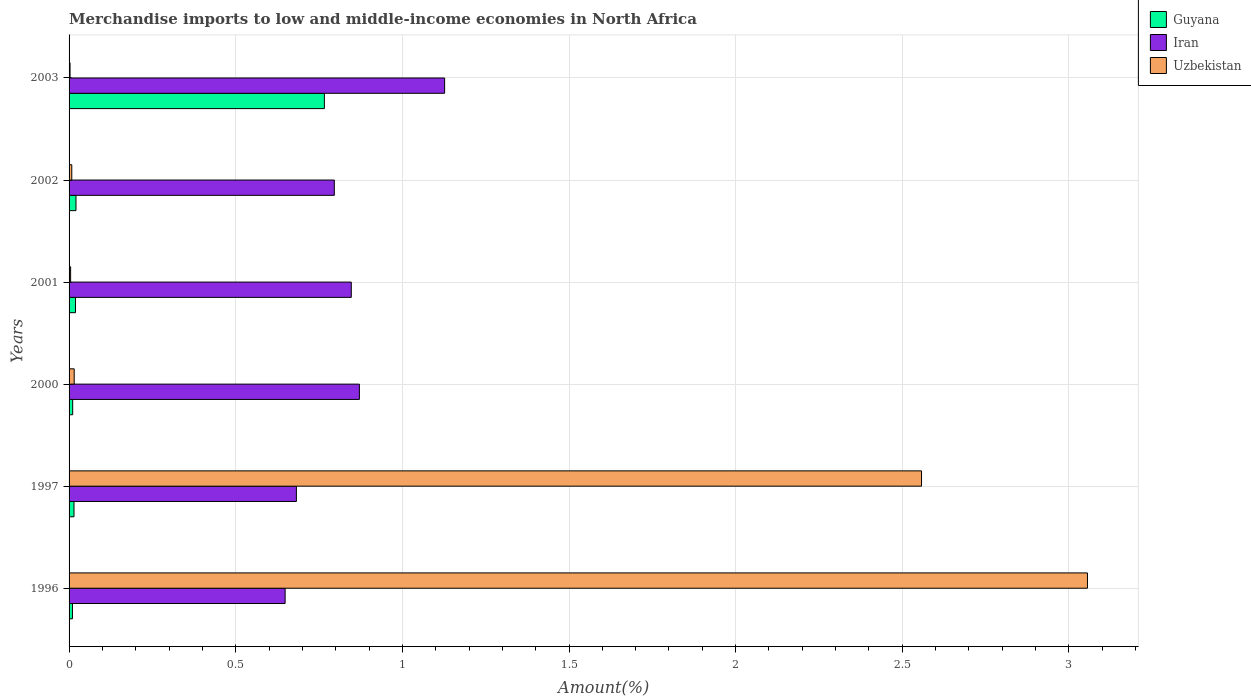How many different coloured bars are there?
Offer a very short reply. 3. How many groups of bars are there?
Give a very brief answer. 6. Are the number of bars per tick equal to the number of legend labels?
Your answer should be very brief. Yes. How many bars are there on the 3rd tick from the top?
Provide a succinct answer. 3. In how many cases, is the number of bars for a given year not equal to the number of legend labels?
Give a very brief answer. 0. What is the percentage of amount earned from merchandise imports in Guyana in 2002?
Ensure brevity in your answer.  0.02. Across all years, what is the maximum percentage of amount earned from merchandise imports in Iran?
Provide a succinct answer. 1.13. Across all years, what is the minimum percentage of amount earned from merchandise imports in Uzbekistan?
Provide a short and direct response. 0. In which year was the percentage of amount earned from merchandise imports in Uzbekistan minimum?
Provide a short and direct response. 2003. What is the total percentage of amount earned from merchandise imports in Guyana in the graph?
Your answer should be compact. 0.84. What is the difference between the percentage of amount earned from merchandise imports in Guyana in 1996 and that in 2002?
Keep it short and to the point. -0.01. What is the difference between the percentage of amount earned from merchandise imports in Uzbekistan in 1997 and the percentage of amount earned from merchandise imports in Iran in 2003?
Your answer should be very brief. 1.43. What is the average percentage of amount earned from merchandise imports in Guyana per year?
Provide a succinct answer. 0.14. In the year 2002, what is the difference between the percentage of amount earned from merchandise imports in Guyana and percentage of amount earned from merchandise imports in Iran?
Keep it short and to the point. -0.78. What is the ratio of the percentage of amount earned from merchandise imports in Iran in 1997 to that in 2002?
Provide a short and direct response. 0.86. What is the difference between the highest and the second highest percentage of amount earned from merchandise imports in Uzbekistan?
Your response must be concise. 0.5. What is the difference between the highest and the lowest percentage of amount earned from merchandise imports in Uzbekistan?
Provide a short and direct response. 3.05. In how many years, is the percentage of amount earned from merchandise imports in Uzbekistan greater than the average percentage of amount earned from merchandise imports in Uzbekistan taken over all years?
Keep it short and to the point. 2. Is the sum of the percentage of amount earned from merchandise imports in Iran in 2002 and 2003 greater than the maximum percentage of amount earned from merchandise imports in Guyana across all years?
Your response must be concise. Yes. What does the 3rd bar from the top in 2001 represents?
Your response must be concise. Guyana. What does the 3rd bar from the bottom in 1997 represents?
Keep it short and to the point. Uzbekistan. Are all the bars in the graph horizontal?
Make the answer very short. Yes. How many years are there in the graph?
Make the answer very short. 6. Are the values on the major ticks of X-axis written in scientific E-notation?
Your response must be concise. No. Does the graph contain any zero values?
Your answer should be compact. No. Does the graph contain grids?
Provide a succinct answer. Yes. Where does the legend appear in the graph?
Offer a terse response. Top right. What is the title of the graph?
Provide a succinct answer. Merchandise imports to low and middle-income economies in North Africa. Does "St. Lucia" appear as one of the legend labels in the graph?
Your response must be concise. No. What is the label or title of the X-axis?
Your answer should be very brief. Amount(%). What is the Amount(%) in Guyana in 1996?
Give a very brief answer. 0.01. What is the Amount(%) of Iran in 1996?
Make the answer very short. 0.65. What is the Amount(%) in Uzbekistan in 1996?
Make the answer very short. 3.06. What is the Amount(%) in Guyana in 1997?
Provide a short and direct response. 0.01. What is the Amount(%) of Iran in 1997?
Your response must be concise. 0.68. What is the Amount(%) of Uzbekistan in 1997?
Ensure brevity in your answer.  2.56. What is the Amount(%) of Guyana in 2000?
Give a very brief answer. 0.01. What is the Amount(%) in Iran in 2000?
Provide a succinct answer. 0.87. What is the Amount(%) of Uzbekistan in 2000?
Your answer should be very brief. 0.02. What is the Amount(%) of Guyana in 2001?
Keep it short and to the point. 0.02. What is the Amount(%) of Iran in 2001?
Keep it short and to the point. 0.85. What is the Amount(%) in Uzbekistan in 2001?
Your response must be concise. 0. What is the Amount(%) in Guyana in 2002?
Your answer should be very brief. 0.02. What is the Amount(%) of Iran in 2002?
Your answer should be compact. 0.8. What is the Amount(%) in Uzbekistan in 2002?
Offer a terse response. 0.01. What is the Amount(%) in Guyana in 2003?
Your answer should be very brief. 0.77. What is the Amount(%) in Iran in 2003?
Make the answer very short. 1.13. What is the Amount(%) of Uzbekistan in 2003?
Provide a short and direct response. 0. Across all years, what is the maximum Amount(%) in Guyana?
Keep it short and to the point. 0.77. Across all years, what is the maximum Amount(%) in Iran?
Provide a succinct answer. 1.13. Across all years, what is the maximum Amount(%) in Uzbekistan?
Give a very brief answer. 3.06. Across all years, what is the minimum Amount(%) in Guyana?
Your answer should be compact. 0.01. Across all years, what is the minimum Amount(%) of Iran?
Provide a short and direct response. 0.65. Across all years, what is the minimum Amount(%) in Uzbekistan?
Provide a short and direct response. 0. What is the total Amount(%) of Guyana in the graph?
Offer a terse response. 0.84. What is the total Amount(%) in Iran in the graph?
Your answer should be compact. 4.97. What is the total Amount(%) of Uzbekistan in the graph?
Provide a succinct answer. 5.64. What is the difference between the Amount(%) of Guyana in 1996 and that in 1997?
Offer a terse response. -0. What is the difference between the Amount(%) in Iran in 1996 and that in 1997?
Offer a terse response. -0.03. What is the difference between the Amount(%) in Uzbekistan in 1996 and that in 1997?
Provide a short and direct response. 0.5. What is the difference between the Amount(%) in Guyana in 1996 and that in 2000?
Your answer should be very brief. -0. What is the difference between the Amount(%) of Iran in 1996 and that in 2000?
Your response must be concise. -0.22. What is the difference between the Amount(%) of Uzbekistan in 1996 and that in 2000?
Your answer should be very brief. 3.04. What is the difference between the Amount(%) in Guyana in 1996 and that in 2001?
Provide a succinct answer. -0.01. What is the difference between the Amount(%) of Iran in 1996 and that in 2001?
Provide a short and direct response. -0.2. What is the difference between the Amount(%) of Uzbekistan in 1996 and that in 2001?
Your answer should be compact. 3.05. What is the difference between the Amount(%) in Guyana in 1996 and that in 2002?
Your answer should be compact. -0.01. What is the difference between the Amount(%) in Iran in 1996 and that in 2002?
Your answer should be very brief. -0.15. What is the difference between the Amount(%) of Uzbekistan in 1996 and that in 2002?
Make the answer very short. 3.05. What is the difference between the Amount(%) of Guyana in 1996 and that in 2003?
Keep it short and to the point. -0.76. What is the difference between the Amount(%) of Iran in 1996 and that in 2003?
Offer a very short reply. -0.48. What is the difference between the Amount(%) in Uzbekistan in 1996 and that in 2003?
Keep it short and to the point. 3.05. What is the difference between the Amount(%) in Guyana in 1997 and that in 2000?
Your response must be concise. 0. What is the difference between the Amount(%) of Iran in 1997 and that in 2000?
Offer a very short reply. -0.19. What is the difference between the Amount(%) of Uzbekistan in 1997 and that in 2000?
Your answer should be compact. 2.54. What is the difference between the Amount(%) of Guyana in 1997 and that in 2001?
Provide a succinct answer. -0. What is the difference between the Amount(%) in Iran in 1997 and that in 2001?
Your answer should be compact. -0.16. What is the difference between the Amount(%) in Uzbekistan in 1997 and that in 2001?
Ensure brevity in your answer.  2.55. What is the difference between the Amount(%) of Guyana in 1997 and that in 2002?
Keep it short and to the point. -0.01. What is the difference between the Amount(%) in Iran in 1997 and that in 2002?
Ensure brevity in your answer.  -0.11. What is the difference between the Amount(%) in Uzbekistan in 1997 and that in 2002?
Provide a short and direct response. 2.55. What is the difference between the Amount(%) in Guyana in 1997 and that in 2003?
Your response must be concise. -0.75. What is the difference between the Amount(%) of Iran in 1997 and that in 2003?
Provide a succinct answer. -0.44. What is the difference between the Amount(%) of Uzbekistan in 1997 and that in 2003?
Provide a succinct answer. 2.55. What is the difference between the Amount(%) in Guyana in 2000 and that in 2001?
Ensure brevity in your answer.  -0.01. What is the difference between the Amount(%) in Iran in 2000 and that in 2001?
Give a very brief answer. 0.02. What is the difference between the Amount(%) of Uzbekistan in 2000 and that in 2001?
Provide a short and direct response. 0.01. What is the difference between the Amount(%) in Guyana in 2000 and that in 2002?
Make the answer very short. -0.01. What is the difference between the Amount(%) in Iran in 2000 and that in 2002?
Your response must be concise. 0.08. What is the difference between the Amount(%) in Uzbekistan in 2000 and that in 2002?
Your answer should be very brief. 0.01. What is the difference between the Amount(%) in Guyana in 2000 and that in 2003?
Your response must be concise. -0.76. What is the difference between the Amount(%) of Iran in 2000 and that in 2003?
Ensure brevity in your answer.  -0.26. What is the difference between the Amount(%) in Uzbekistan in 2000 and that in 2003?
Your answer should be very brief. 0.01. What is the difference between the Amount(%) of Guyana in 2001 and that in 2002?
Your answer should be very brief. -0. What is the difference between the Amount(%) of Iran in 2001 and that in 2002?
Ensure brevity in your answer.  0.05. What is the difference between the Amount(%) of Uzbekistan in 2001 and that in 2002?
Give a very brief answer. -0. What is the difference between the Amount(%) in Guyana in 2001 and that in 2003?
Provide a succinct answer. -0.75. What is the difference between the Amount(%) in Iran in 2001 and that in 2003?
Keep it short and to the point. -0.28. What is the difference between the Amount(%) of Uzbekistan in 2001 and that in 2003?
Provide a succinct answer. 0. What is the difference between the Amount(%) of Guyana in 2002 and that in 2003?
Your answer should be very brief. -0.75. What is the difference between the Amount(%) of Iran in 2002 and that in 2003?
Provide a succinct answer. -0.33. What is the difference between the Amount(%) in Uzbekistan in 2002 and that in 2003?
Offer a very short reply. 0.01. What is the difference between the Amount(%) of Guyana in 1996 and the Amount(%) of Iran in 1997?
Offer a very short reply. -0.67. What is the difference between the Amount(%) of Guyana in 1996 and the Amount(%) of Uzbekistan in 1997?
Provide a succinct answer. -2.55. What is the difference between the Amount(%) of Iran in 1996 and the Amount(%) of Uzbekistan in 1997?
Ensure brevity in your answer.  -1.91. What is the difference between the Amount(%) of Guyana in 1996 and the Amount(%) of Iran in 2000?
Give a very brief answer. -0.86. What is the difference between the Amount(%) of Guyana in 1996 and the Amount(%) of Uzbekistan in 2000?
Provide a short and direct response. -0.01. What is the difference between the Amount(%) of Iran in 1996 and the Amount(%) of Uzbekistan in 2000?
Keep it short and to the point. 0.63. What is the difference between the Amount(%) of Guyana in 1996 and the Amount(%) of Iran in 2001?
Make the answer very short. -0.84. What is the difference between the Amount(%) in Guyana in 1996 and the Amount(%) in Uzbekistan in 2001?
Your answer should be compact. 0.01. What is the difference between the Amount(%) of Iran in 1996 and the Amount(%) of Uzbekistan in 2001?
Your answer should be very brief. 0.64. What is the difference between the Amount(%) of Guyana in 1996 and the Amount(%) of Iran in 2002?
Keep it short and to the point. -0.79. What is the difference between the Amount(%) of Guyana in 1996 and the Amount(%) of Uzbekistan in 2002?
Provide a succinct answer. 0. What is the difference between the Amount(%) of Iran in 1996 and the Amount(%) of Uzbekistan in 2002?
Keep it short and to the point. 0.64. What is the difference between the Amount(%) in Guyana in 1996 and the Amount(%) in Iran in 2003?
Offer a terse response. -1.12. What is the difference between the Amount(%) of Guyana in 1996 and the Amount(%) of Uzbekistan in 2003?
Give a very brief answer. 0.01. What is the difference between the Amount(%) of Iran in 1996 and the Amount(%) of Uzbekistan in 2003?
Your answer should be very brief. 0.65. What is the difference between the Amount(%) of Guyana in 1997 and the Amount(%) of Iran in 2000?
Make the answer very short. -0.86. What is the difference between the Amount(%) of Guyana in 1997 and the Amount(%) of Uzbekistan in 2000?
Offer a terse response. -0. What is the difference between the Amount(%) of Iran in 1997 and the Amount(%) of Uzbekistan in 2000?
Offer a very short reply. 0.67. What is the difference between the Amount(%) in Guyana in 1997 and the Amount(%) in Iran in 2001?
Offer a terse response. -0.83. What is the difference between the Amount(%) of Guyana in 1997 and the Amount(%) of Uzbekistan in 2001?
Your answer should be very brief. 0.01. What is the difference between the Amount(%) of Iran in 1997 and the Amount(%) of Uzbekistan in 2001?
Keep it short and to the point. 0.68. What is the difference between the Amount(%) of Guyana in 1997 and the Amount(%) of Iran in 2002?
Your response must be concise. -0.78. What is the difference between the Amount(%) in Guyana in 1997 and the Amount(%) in Uzbekistan in 2002?
Your response must be concise. 0.01. What is the difference between the Amount(%) in Iran in 1997 and the Amount(%) in Uzbekistan in 2002?
Provide a succinct answer. 0.67. What is the difference between the Amount(%) of Guyana in 1997 and the Amount(%) of Iran in 2003?
Offer a terse response. -1.11. What is the difference between the Amount(%) of Guyana in 1997 and the Amount(%) of Uzbekistan in 2003?
Your answer should be very brief. 0.01. What is the difference between the Amount(%) in Iran in 1997 and the Amount(%) in Uzbekistan in 2003?
Provide a short and direct response. 0.68. What is the difference between the Amount(%) of Guyana in 2000 and the Amount(%) of Iran in 2001?
Your answer should be compact. -0.84. What is the difference between the Amount(%) in Guyana in 2000 and the Amount(%) in Uzbekistan in 2001?
Provide a short and direct response. 0.01. What is the difference between the Amount(%) of Iran in 2000 and the Amount(%) of Uzbekistan in 2001?
Your response must be concise. 0.87. What is the difference between the Amount(%) in Guyana in 2000 and the Amount(%) in Iran in 2002?
Ensure brevity in your answer.  -0.79. What is the difference between the Amount(%) of Guyana in 2000 and the Amount(%) of Uzbekistan in 2002?
Offer a very short reply. 0. What is the difference between the Amount(%) in Iran in 2000 and the Amount(%) in Uzbekistan in 2002?
Your response must be concise. 0.86. What is the difference between the Amount(%) of Guyana in 2000 and the Amount(%) of Iran in 2003?
Provide a succinct answer. -1.12. What is the difference between the Amount(%) of Guyana in 2000 and the Amount(%) of Uzbekistan in 2003?
Provide a short and direct response. 0.01. What is the difference between the Amount(%) of Iran in 2000 and the Amount(%) of Uzbekistan in 2003?
Your answer should be compact. 0.87. What is the difference between the Amount(%) of Guyana in 2001 and the Amount(%) of Iran in 2002?
Ensure brevity in your answer.  -0.78. What is the difference between the Amount(%) of Guyana in 2001 and the Amount(%) of Uzbekistan in 2002?
Offer a very short reply. 0.01. What is the difference between the Amount(%) of Iran in 2001 and the Amount(%) of Uzbekistan in 2002?
Give a very brief answer. 0.84. What is the difference between the Amount(%) in Guyana in 2001 and the Amount(%) in Iran in 2003?
Give a very brief answer. -1.11. What is the difference between the Amount(%) in Guyana in 2001 and the Amount(%) in Uzbekistan in 2003?
Offer a very short reply. 0.02. What is the difference between the Amount(%) in Iran in 2001 and the Amount(%) in Uzbekistan in 2003?
Ensure brevity in your answer.  0.84. What is the difference between the Amount(%) in Guyana in 2002 and the Amount(%) in Iran in 2003?
Keep it short and to the point. -1.11. What is the difference between the Amount(%) of Guyana in 2002 and the Amount(%) of Uzbekistan in 2003?
Keep it short and to the point. 0.02. What is the difference between the Amount(%) of Iran in 2002 and the Amount(%) of Uzbekistan in 2003?
Offer a terse response. 0.79. What is the average Amount(%) in Guyana per year?
Your answer should be compact. 0.14. What is the average Amount(%) of Iran per year?
Your response must be concise. 0.83. What is the average Amount(%) in Uzbekistan per year?
Offer a very short reply. 0.94. In the year 1996, what is the difference between the Amount(%) of Guyana and Amount(%) of Iran?
Your answer should be compact. -0.64. In the year 1996, what is the difference between the Amount(%) in Guyana and Amount(%) in Uzbekistan?
Provide a short and direct response. -3.05. In the year 1996, what is the difference between the Amount(%) of Iran and Amount(%) of Uzbekistan?
Your answer should be compact. -2.41. In the year 1997, what is the difference between the Amount(%) of Guyana and Amount(%) of Iran?
Your response must be concise. -0.67. In the year 1997, what is the difference between the Amount(%) in Guyana and Amount(%) in Uzbekistan?
Offer a very short reply. -2.54. In the year 1997, what is the difference between the Amount(%) of Iran and Amount(%) of Uzbekistan?
Make the answer very short. -1.88. In the year 2000, what is the difference between the Amount(%) of Guyana and Amount(%) of Iran?
Offer a very short reply. -0.86. In the year 2000, what is the difference between the Amount(%) of Guyana and Amount(%) of Uzbekistan?
Make the answer very short. -0. In the year 2000, what is the difference between the Amount(%) in Iran and Amount(%) in Uzbekistan?
Provide a short and direct response. 0.86. In the year 2001, what is the difference between the Amount(%) of Guyana and Amount(%) of Iran?
Keep it short and to the point. -0.83. In the year 2001, what is the difference between the Amount(%) in Guyana and Amount(%) in Uzbekistan?
Your answer should be compact. 0.01. In the year 2001, what is the difference between the Amount(%) of Iran and Amount(%) of Uzbekistan?
Your response must be concise. 0.84. In the year 2002, what is the difference between the Amount(%) of Guyana and Amount(%) of Iran?
Your answer should be very brief. -0.78. In the year 2002, what is the difference between the Amount(%) in Guyana and Amount(%) in Uzbekistan?
Make the answer very short. 0.01. In the year 2002, what is the difference between the Amount(%) of Iran and Amount(%) of Uzbekistan?
Keep it short and to the point. 0.79. In the year 2003, what is the difference between the Amount(%) of Guyana and Amount(%) of Iran?
Give a very brief answer. -0.36. In the year 2003, what is the difference between the Amount(%) of Guyana and Amount(%) of Uzbekistan?
Your answer should be very brief. 0.76. In the year 2003, what is the difference between the Amount(%) in Iran and Amount(%) in Uzbekistan?
Provide a short and direct response. 1.12. What is the ratio of the Amount(%) of Guyana in 1996 to that in 1997?
Your response must be concise. 0.69. What is the ratio of the Amount(%) in Iran in 1996 to that in 1997?
Offer a terse response. 0.95. What is the ratio of the Amount(%) in Uzbekistan in 1996 to that in 1997?
Your answer should be compact. 1.19. What is the ratio of the Amount(%) in Guyana in 1996 to that in 2000?
Give a very brief answer. 0.93. What is the ratio of the Amount(%) in Iran in 1996 to that in 2000?
Your answer should be very brief. 0.74. What is the ratio of the Amount(%) in Uzbekistan in 1996 to that in 2000?
Provide a succinct answer. 198.33. What is the ratio of the Amount(%) in Guyana in 1996 to that in 2001?
Your response must be concise. 0.53. What is the ratio of the Amount(%) of Iran in 1996 to that in 2001?
Your answer should be compact. 0.77. What is the ratio of the Amount(%) in Uzbekistan in 1996 to that in 2001?
Make the answer very short. 654.3. What is the ratio of the Amount(%) of Guyana in 1996 to that in 2002?
Offer a very short reply. 0.49. What is the ratio of the Amount(%) in Iran in 1996 to that in 2002?
Provide a short and direct response. 0.81. What is the ratio of the Amount(%) in Uzbekistan in 1996 to that in 2002?
Ensure brevity in your answer.  376.32. What is the ratio of the Amount(%) of Guyana in 1996 to that in 2003?
Your answer should be very brief. 0.01. What is the ratio of the Amount(%) of Iran in 1996 to that in 2003?
Your answer should be very brief. 0.58. What is the ratio of the Amount(%) in Uzbekistan in 1996 to that in 2003?
Your answer should be very brief. 1039.62. What is the ratio of the Amount(%) in Guyana in 1997 to that in 2000?
Your answer should be very brief. 1.36. What is the ratio of the Amount(%) of Iran in 1997 to that in 2000?
Provide a short and direct response. 0.78. What is the ratio of the Amount(%) in Uzbekistan in 1997 to that in 2000?
Provide a short and direct response. 166.02. What is the ratio of the Amount(%) in Guyana in 1997 to that in 2001?
Your answer should be very brief. 0.77. What is the ratio of the Amount(%) of Iran in 1997 to that in 2001?
Offer a very short reply. 0.81. What is the ratio of the Amount(%) in Uzbekistan in 1997 to that in 2001?
Offer a terse response. 547.69. What is the ratio of the Amount(%) of Guyana in 1997 to that in 2002?
Make the answer very short. 0.71. What is the ratio of the Amount(%) in Iran in 1997 to that in 2002?
Your response must be concise. 0.86. What is the ratio of the Amount(%) of Uzbekistan in 1997 to that in 2002?
Offer a terse response. 315. What is the ratio of the Amount(%) of Guyana in 1997 to that in 2003?
Offer a terse response. 0.02. What is the ratio of the Amount(%) in Iran in 1997 to that in 2003?
Your response must be concise. 0.61. What is the ratio of the Amount(%) in Uzbekistan in 1997 to that in 2003?
Your answer should be very brief. 870.23. What is the ratio of the Amount(%) in Guyana in 2000 to that in 2001?
Give a very brief answer. 0.56. What is the ratio of the Amount(%) of Iran in 2000 to that in 2001?
Your response must be concise. 1.03. What is the ratio of the Amount(%) in Uzbekistan in 2000 to that in 2001?
Your answer should be very brief. 3.3. What is the ratio of the Amount(%) in Guyana in 2000 to that in 2002?
Offer a very short reply. 0.52. What is the ratio of the Amount(%) in Iran in 2000 to that in 2002?
Provide a short and direct response. 1.09. What is the ratio of the Amount(%) of Uzbekistan in 2000 to that in 2002?
Offer a very short reply. 1.9. What is the ratio of the Amount(%) of Guyana in 2000 to that in 2003?
Your answer should be very brief. 0.01. What is the ratio of the Amount(%) in Iran in 2000 to that in 2003?
Your response must be concise. 0.77. What is the ratio of the Amount(%) of Uzbekistan in 2000 to that in 2003?
Provide a succinct answer. 5.24. What is the ratio of the Amount(%) of Guyana in 2001 to that in 2002?
Give a very brief answer. 0.93. What is the ratio of the Amount(%) in Iran in 2001 to that in 2002?
Make the answer very short. 1.06. What is the ratio of the Amount(%) of Uzbekistan in 2001 to that in 2002?
Your response must be concise. 0.58. What is the ratio of the Amount(%) in Guyana in 2001 to that in 2003?
Your answer should be very brief. 0.03. What is the ratio of the Amount(%) in Iran in 2001 to that in 2003?
Make the answer very short. 0.75. What is the ratio of the Amount(%) in Uzbekistan in 2001 to that in 2003?
Provide a succinct answer. 1.59. What is the ratio of the Amount(%) in Guyana in 2002 to that in 2003?
Offer a terse response. 0.03. What is the ratio of the Amount(%) of Iran in 2002 to that in 2003?
Offer a terse response. 0.71. What is the ratio of the Amount(%) of Uzbekistan in 2002 to that in 2003?
Make the answer very short. 2.76. What is the difference between the highest and the second highest Amount(%) of Guyana?
Keep it short and to the point. 0.75. What is the difference between the highest and the second highest Amount(%) in Iran?
Provide a short and direct response. 0.26. What is the difference between the highest and the second highest Amount(%) of Uzbekistan?
Give a very brief answer. 0.5. What is the difference between the highest and the lowest Amount(%) in Guyana?
Your answer should be compact. 0.76. What is the difference between the highest and the lowest Amount(%) in Iran?
Offer a terse response. 0.48. What is the difference between the highest and the lowest Amount(%) in Uzbekistan?
Keep it short and to the point. 3.05. 